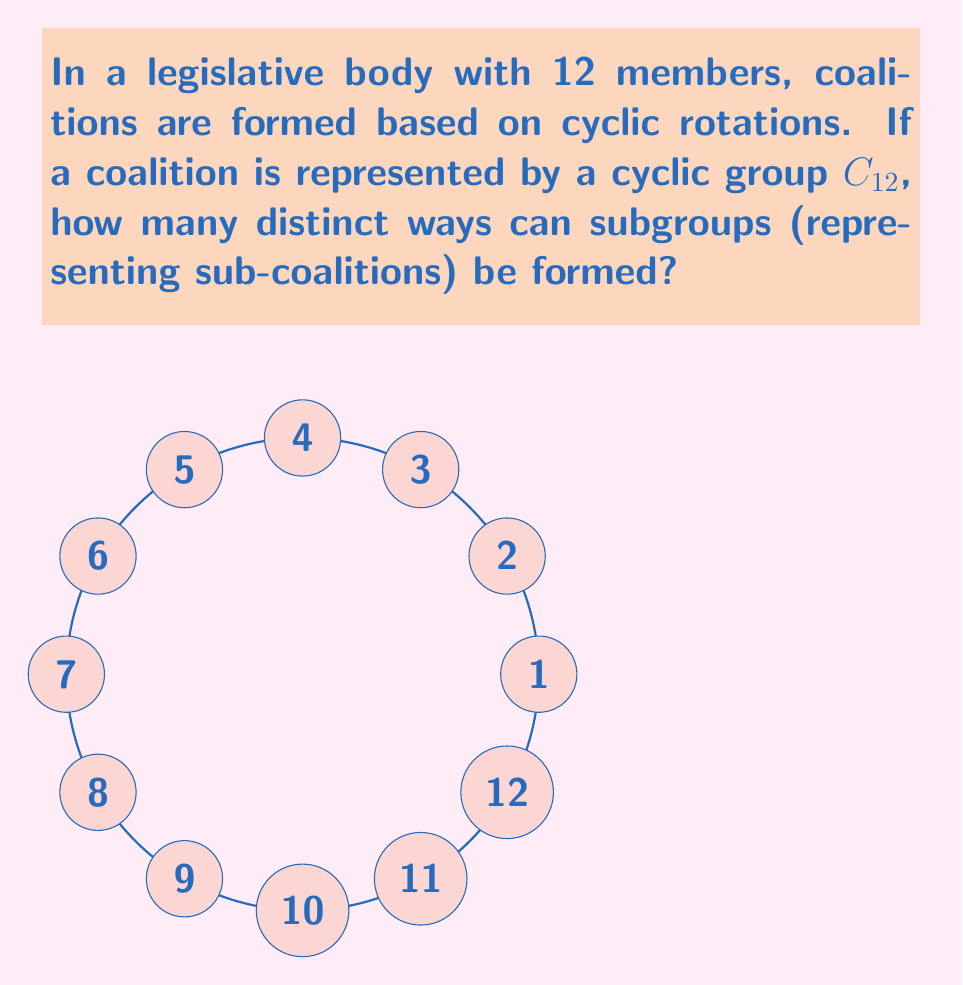Help me with this question. To solve this problem, we need to follow these steps:

1) First, recall that the number of subgroups in a cyclic group $C_n$ is equal to the number of divisors of $n$.

2) In this case, we have $C_{12}$, so we need to find the divisors of 12.

3) The divisors of 12 are: 1, 2, 3, 4, 6, and 12.

4) Each of these divisors corresponds to a subgroup:
   - $\{e\}$ (identity element only) for divisor 1
   - $\{e, 6\}$ for divisor 2
   - $\{e, 4, 8\}$ for divisor 3
   - $\{e, 3, 6, 9\}$ for divisor 4
   - $\{e, 2, 4, 6, 8, 10\}$ for divisor 6
   - The entire group for divisor 12

5) Therefore, the number of distinct subgroups (sub-coalitions) is equal to the number of divisors of 12.

6) Count the divisors: 1, 2, 3, 4, 6, 12. There are 6 divisors.

Thus, there are 6 distinct ways to form sub-coalitions using cyclic subgroups of $C_{12}$.
Answer: 6 